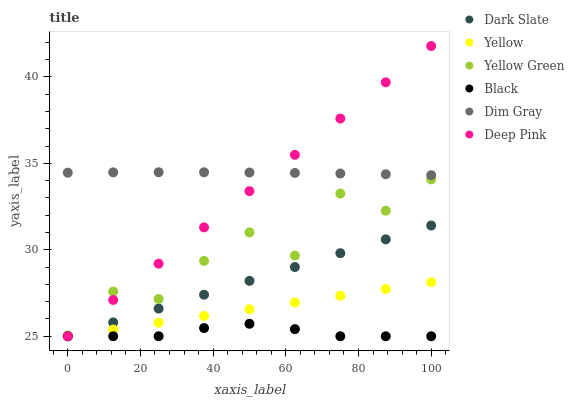Does Black have the minimum area under the curve?
Answer yes or no. Yes. Does Dim Gray have the maximum area under the curve?
Answer yes or no. Yes. Does Yellow Green have the minimum area under the curve?
Answer yes or no. No. Does Yellow Green have the maximum area under the curve?
Answer yes or no. No. Is Dark Slate the smoothest?
Answer yes or no. Yes. Is Yellow Green the roughest?
Answer yes or no. Yes. Is Yellow the smoothest?
Answer yes or no. No. Is Yellow the roughest?
Answer yes or no. No. Does Yellow have the lowest value?
Answer yes or no. Yes. Does Yellow Green have the lowest value?
Answer yes or no. No. Does Deep Pink have the highest value?
Answer yes or no. Yes. Does Yellow Green have the highest value?
Answer yes or no. No. Is Dark Slate less than Yellow Green?
Answer yes or no. Yes. Is Dim Gray greater than Yellow Green?
Answer yes or no. Yes. Does Dim Gray intersect Deep Pink?
Answer yes or no. Yes. Is Dim Gray less than Deep Pink?
Answer yes or no. No. Is Dim Gray greater than Deep Pink?
Answer yes or no. No. Does Dark Slate intersect Yellow Green?
Answer yes or no. No. 